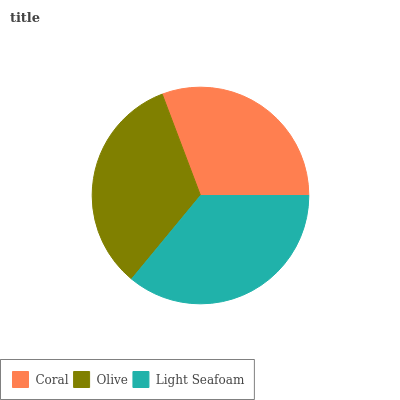Is Coral the minimum?
Answer yes or no. Yes. Is Light Seafoam the maximum?
Answer yes or no. Yes. Is Olive the minimum?
Answer yes or no. No. Is Olive the maximum?
Answer yes or no. No. Is Olive greater than Coral?
Answer yes or no. Yes. Is Coral less than Olive?
Answer yes or no. Yes. Is Coral greater than Olive?
Answer yes or no. No. Is Olive less than Coral?
Answer yes or no. No. Is Olive the high median?
Answer yes or no. Yes. Is Olive the low median?
Answer yes or no. Yes. Is Coral the high median?
Answer yes or no. No. Is Coral the low median?
Answer yes or no. No. 